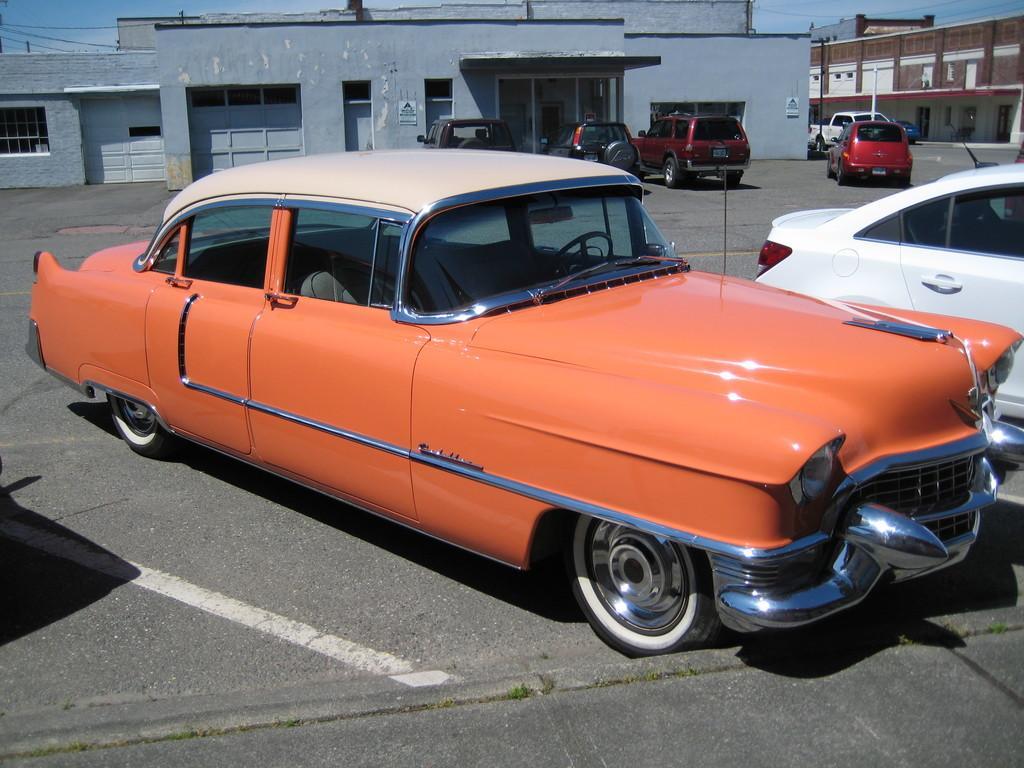Describe this image in one or two sentences. In this image we can see few cars, buildings, windows, poles, also we can see the sky. 